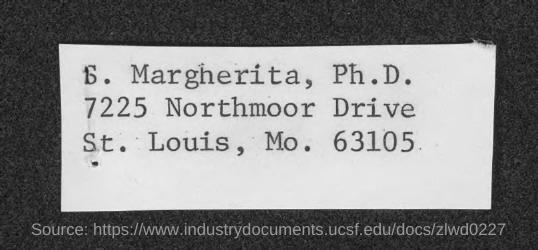Whose name is given?
Ensure brevity in your answer.  S. Margherita. What is the zip code mentioned?
Keep it short and to the point. 63105. 